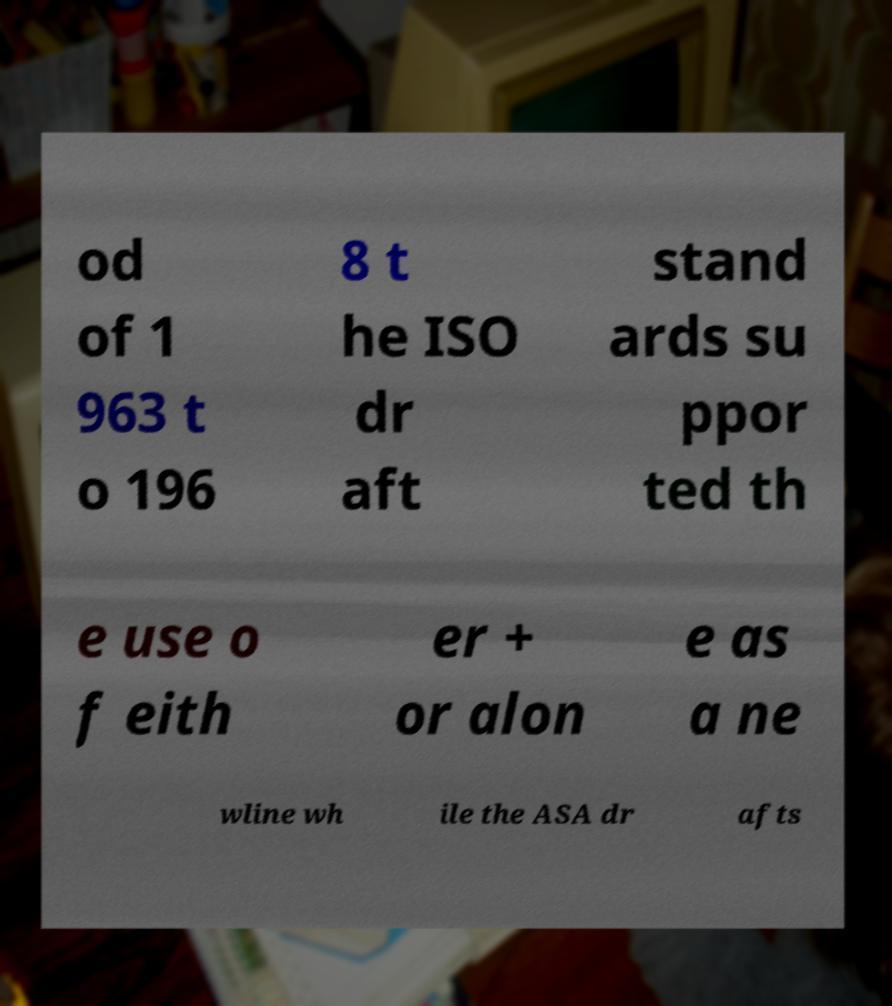Please identify and transcribe the text found in this image. od of 1 963 t o 196 8 t he ISO dr aft stand ards su ppor ted th e use o f eith er + or alon e as a ne wline wh ile the ASA dr afts 